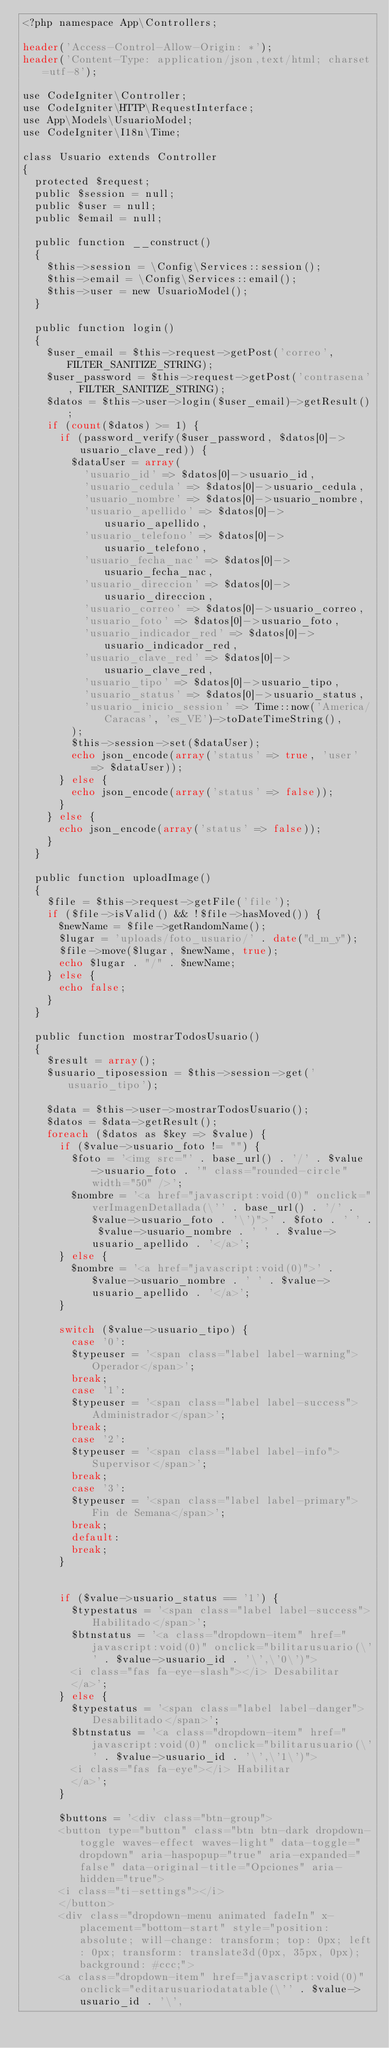<code> <loc_0><loc_0><loc_500><loc_500><_PHP_><?php namespace App\Controllers;

header('Access-Control-Allow-Origin: *');
header('Content-Type: application/json,text/html; charset=utf-8');

use CodeIgniter\Controller;
use CodeIgniter\HTTP\RequestInterface;
use App\Models\UsuarioModel;
use CodeIgniter\I18n\Time;

class Usuario extends Controller
{
  protected $request;
  public $session = null;
  public $user = null;
  public $email = null;

  public function __construct()
  {
    $this->session = \Config\Services::session();
    $this->email = \Config\Services::email();
    $this->user = new UsuarioModel();
  }

  public function login()
  {
    $user_email = $this->request->getPost('correo', FILTER_SANITIZE_STRING);
    $user_password = $this->request->getPost('contrasena', FILTER_SANITIZE_STRING);
    $datos = $this->user->login($user_email)->getResult();
    if (count($datos) >= 1) {
      if (password_verify($user_password, $datos[0]->usuario_clave_red)) {
        $dataUser = array(
          'usuario_id' => $datos[0]->usuario_id,
          'usuario_cedula' => $datos[0]->usuario_cedula,
          'usuario_nombre' => $datos[0]->usuario_nombre,
          'usuario_apellido' => $datos[0]->usuario_apellido,
          'usuario_telefono' => $datos[0]->usuario_telefono,
          'usuario_fecha_nac' => $datos[0]->usuario_fecha_nac,
          'usuario_direccion' => $datos[0]->usuario_direccion,
          'usuario_correo' => $datos[0]->usuario_correo,
          'usuario_foto' => $datos[0]->usuario_foto,
          'usuario_indicador_red' => $datos[0]->usuario_indicador_red,
          'usuario_clave_red' => $datos[0]->usuario_clave_red,
          'usuario_tipo' => $datos[0]->usuario_tipo,
          'usuario_status' => $datos[0]->usuario_status,
          'usuario_inicio_session' => Time::now('America/Caracas', 'es_VE')->toDateTimeString(),
        );
        $this->session->set($dataUser);
        echo json_encode(array('status' => true, 'user' => $dataUser));
      } else {
        echo json_encode(array('status' => false));
      }
    } else {
      echo json_encode(array('status' => false));
    }
  }

  public function uploadImage()
  {
    $file = $this->request->getFile('file');
    if ($file->isValid() && !$file->hasMoved()) {
      $newName = $file->getRandomName();
      $lugar = 'uploads/foto_usuario/' . date("d_m_y");
      $file->move($lugar, $newName, true);
      echo $lugar . "/" . $newName;
    } else {
      echo false;
    }
  }

  public function mostrarTodosUsuario()
  {
    $result = array();
    $usuario_tiposession = $this->session->get('usuario_tipo');

    $data = $this->user->mostrarTodosUsuario();
    $datos = $data->getResult();
    foreach ($datos as $key => $value) {
      if ($value->usuario_foto != "") {
        $foto = '<img src="' . base_url() . '/' . $value->usuario_foto . '" class="rounded-circle" width="50" />';
        $nombre = '<a href="javascript:void(0)" onclick="verImagenDetallada(\'' . base_url() . '/' . $value->usuario_foto . '\')">' . $foto . ' ' . $value->usuario_nombre . ' ' . $value->usuario_apellido . '</a>';
      } else {
        $nombre = '<a href="javascript:void(0)">' . $value->usuario_nombre . ' ' . $value->usuario_apellido . '</a>';
      }

      switch ($value->usuario_tipo) {
        case '0':
        $typeuser = '<span class="label label-warning">Operador</span>';
        break;
        case '1':
        $typeuser = '<span class="label label-success">Administrador</span>';
        break;
        case '2':
        $typeuser = '<span class="label label-info">Supervisor</span>';
        break;
        case '3':
        $typeuser = '<span class="label label-primary">Fin de Semana</span>';
        break;
        default:
        break;
      }


      if ($value->usuario_status == '1') {
        $typestatus = '<span class="label label-success">Habilitado</span>';
        $btnstatus = '<a class="dropdown-item" href="javascript:void(0)" onclick="bilitarusuario(\'' . $value->usuario_id . '\',\'0\')">
        <i class="fas fa-eye-slash"></i> Desabilitar
        </a>';
      } else {
        $typestatus = '<span class="label label-danger">Desabilitado</span>';
        $btnstatus = '<a class="dropdown-item" href="javascript:void(0)" onclick="bilitarusuario(\'' . $value->usuario_id . '\',\'1\')">
        <i class="fas fa-eye"></i> Habilitar
        </a>';
      }

      $buttons = '<div class="btn-group">
      <button type="button" class="btn btn-dark dropdown-toggle waves-effect waves-light" data-toggle="dropdown" aria-haspopup="true" aria-expanded="false" data-original-title="Opciones" aria-hidden="true">
      <i class="ti-settings"></i>
      </button>
      <div class="dropdown-menu animated fadeIn" x-placement="bottom-start" style="position: absolute; will-change: transform; top: 0px; left: 0px; transform: translate3d(0px, 35px, 0px); background: #ccc;">
      <a class="dropdown-item" href="javascript:void(0)" onclick="editarusuariodatatable(\'' . $value->usuario_id . '\',</code> 